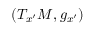<formula> <loc_0><loc_0><loc_500><loc_500>( T _ { x ^ { \prime } } M , g _ { x ^ { \prime } } )</formula> 